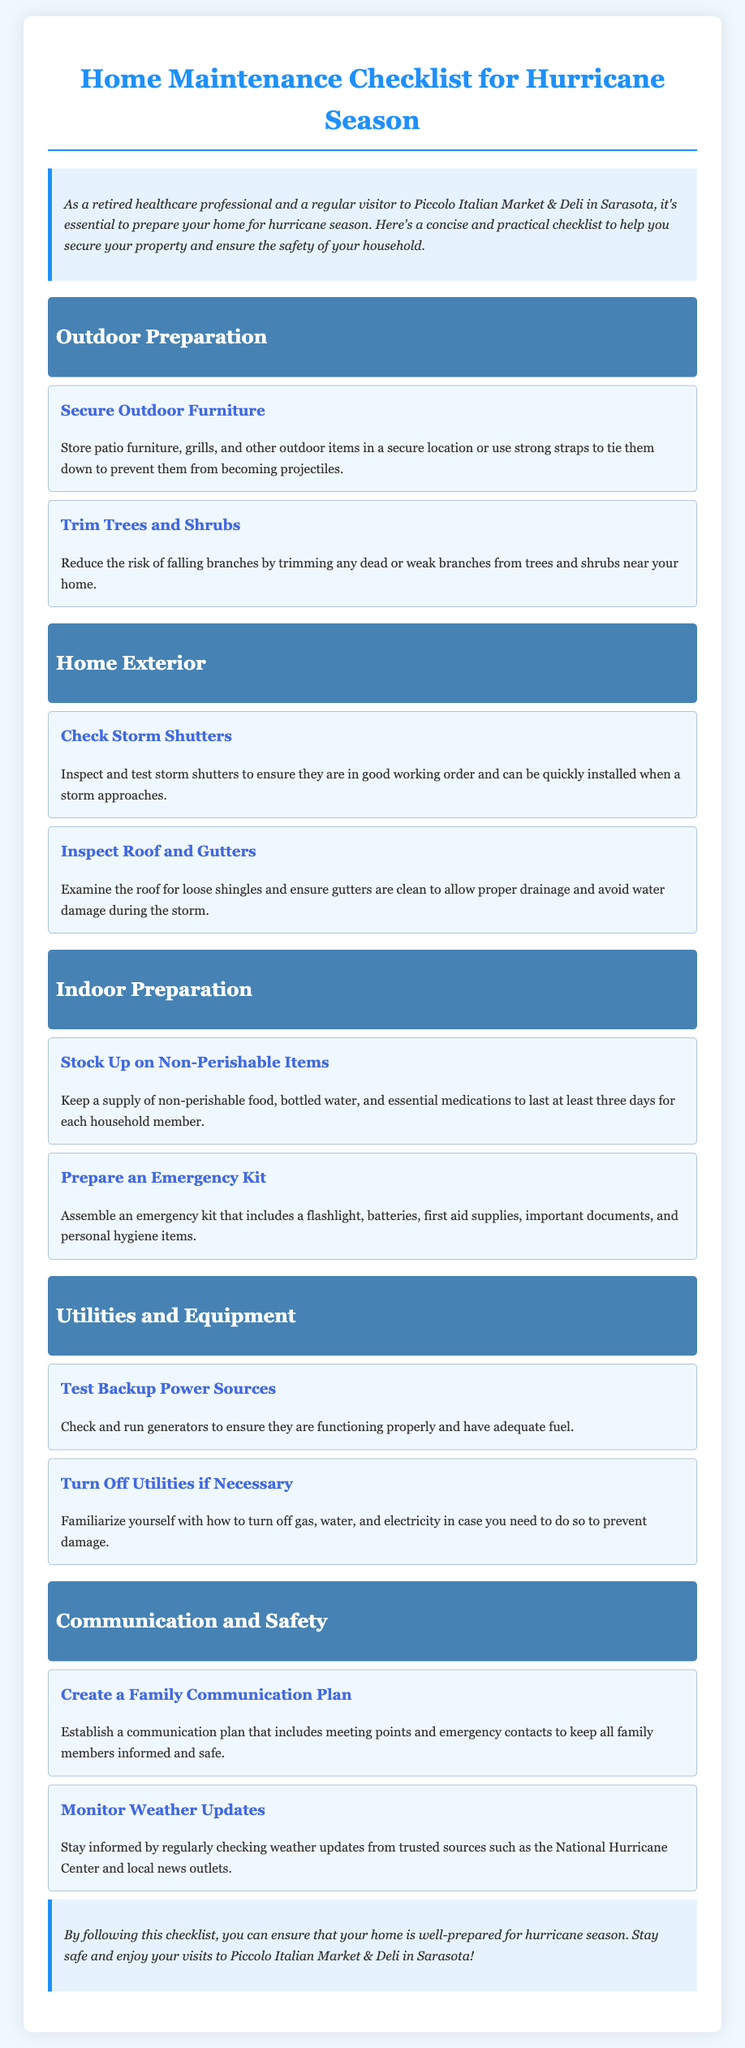What is the title of the document? The title of the document is presented prominently at the top of the page.
Answer: Home Maintenance Checklist for Hurricane Season How many categories are in the checklist? The document outlines multiple sections for organization, specifically referring to categories.
Answer: 5 What should you store away for storm preparation? This task pertains to a specific action in the outdoor preparation section of the checklist.
Answer: Outdoor furniture What is one item to keep in the emergency kit? The emergency kit includes various essential items for preparedness.
Answer: Flashlight How many days of non-perishable items should you stock up on? The document specifies a duration for which supplies should be kept in case of an emergency.
Answer: At least three days What should you do to trees and shrubs? This task focuses on reducing potential hazards in outdoor areas surrounding the home.
Answer: Trim What source should you check for weather updates? The checklist mentions a reliable source of information for monitoring weather conditions.
Answer: National Hurricane Center What is the purpose of testing backup power sources? This action is to ensure the effectiveness of a specific type of equipment in emergencies.
Answer: Functionality What is the color of the category headings? The document specifies the visual presentation of the headings indicating different sections.
Answer: White 